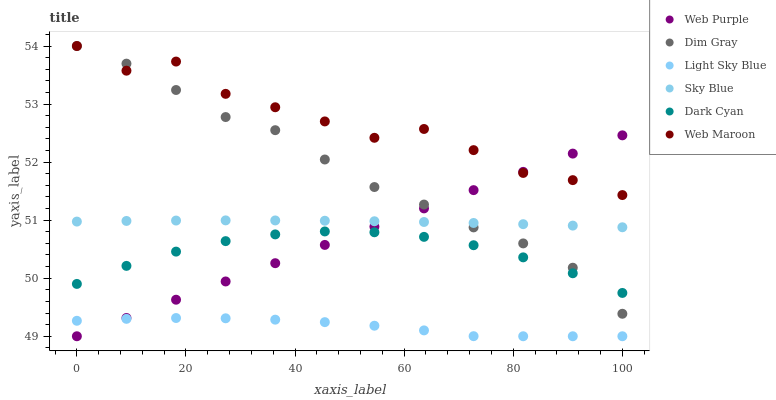Does Light Sky Blue have the minimum area under the curve?
Answer yes or no. Yes. Does Web Maroon have the maximum area under the curve?
Answer yes or no. Yes. Does Web Purple have the minimum area under the curve?
Answer yes or no. No. Does Web Purple have the maximum area under the curve?
Answer yes or no. No. Is Web Purple the smoothest?
Answer yes or no. Yes. Is Web Maroon the roughest?
Answer yes or no. Yes. Is Web Maroon the smoothest?
Answer yes or no. No. Is Web Purple the roughest?
Answer yes or no. No. Does Web Purple have the lowest value?
Answer yes or no. Yes. Does Web Maroon have the lowest value?
Answer yes or no. No. Does Web Maroon have the highest value?
Answer yes or no. Yes. Does Web Purple have the highest value?
Answer yes or no. No. Is Light Sky Blue less than Sky Blue?
Answer yes or no. Yes. Is Sky Blue greater than Light Sky Blue?
Answer yes or no. Yes. Does Dim Gray intersect Sky Blue?
Answer yes or no. Yes. Is Dim Gray less than Sky Blue?
Answer yes or no. No. Is Dim Gray greater than Sky Blue?
Answer yes or no. No. Does Light Sky Blue intersect Sky Blue?
Answer yes or no. No. 